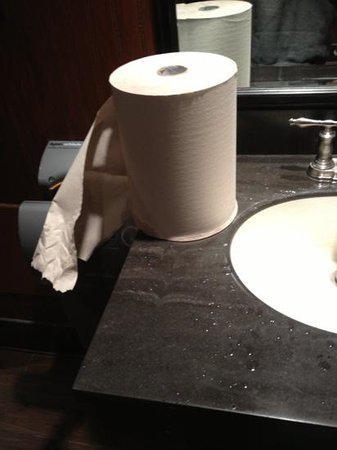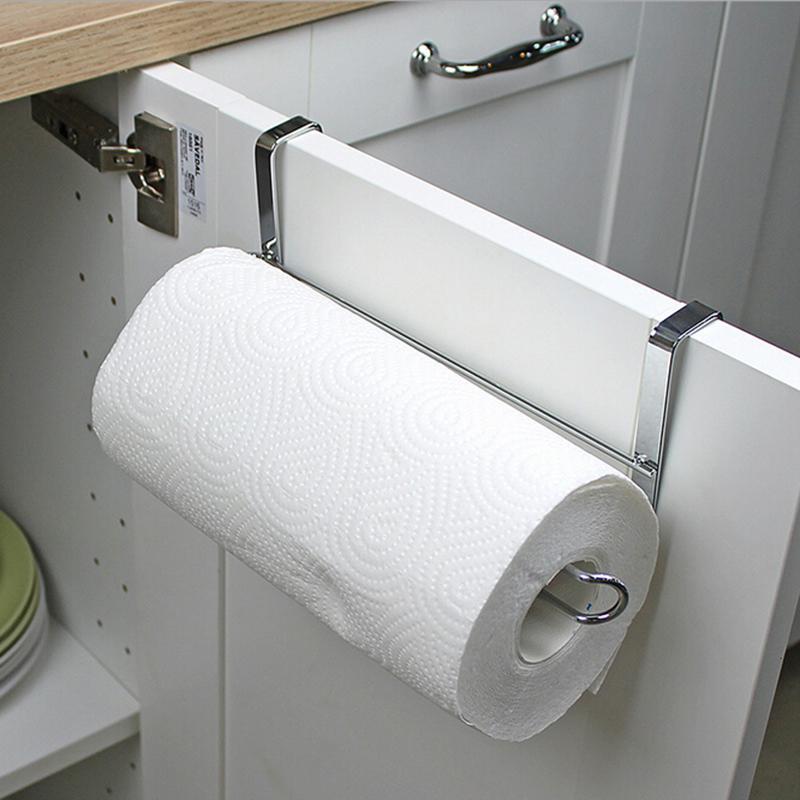The first image is the image on the left, the second image is the image on the right. Analyze the images presented: Is the assertion "In one image, a roll of white paper towels in on a chrome rack attached to the inside of a white cabinet door." valid? Answer yes or no. Yes. The first image is the image on the left, the second image is the image on the right. Assess this claim about the two images: "An image shows one white towel roll mounted on a bar hung on a cabinet door.". Correct or not? Answer yes or no. Yes. 